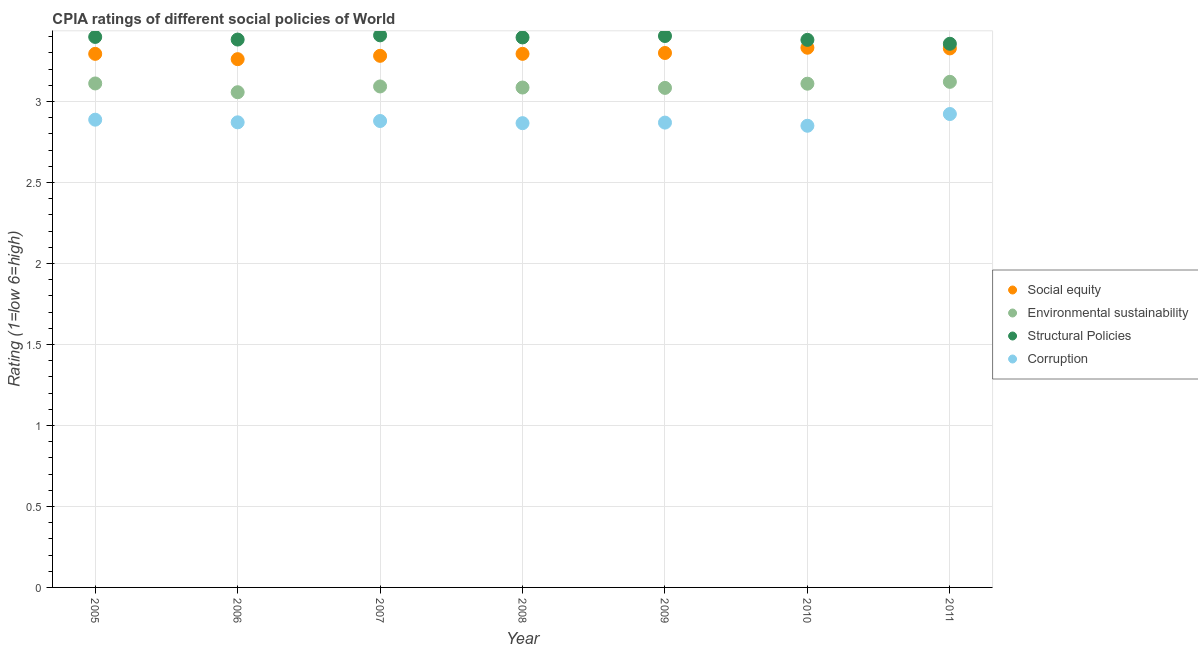How many different coloured dotlines are there?
Offer a very short reply. 4. Across all years, what is the maximum cpia rating of social equity?
Provide a succinct answer. 3.33. Across all years, what is the minimum cpia rating of social equity?
Ensure brevity in your answer.  3.26. In which year was the cpia rating of corruption maximum?
Your response must be concise. 2011. What is the total cpia rating of structural policies in the graph?
Ensure brevity in your answer.  23.73. What is the difference between the cpia rating of corruption in 2009 and that in 2010?
Offer a terse response. 0.02. What is the difference between the cpia rating of corruption in 2007 and the cpia rating of structural policies in 2005?
Your response must be concise. -0.52. What is the average cpia rating of structural policies per year?
Keep it short and to the point. 3.39. In the year 2011, what is the difference between the cpia rating of corruption and cpia rating of environmental sustainability?
Your answer should be very brief. -0.2. What is the ratio of the cpia rating of environmental sustainability in 2009 to that in 2011?
Provide a succinct answer. 0.99. Is the cpia rating of social equity in 2008 less than that in 2009?
Make the answer very short. Yes. Is the difference between the cpia rating of corruption in 2005 and 2011 greater than the difference between the cpia rating of environmental sustainability in 2005 and 2011?
Make the answer very short. No. What is the difference between the highest and the second highest cpia rating of structural policies?
Provide a short and direct response. 0. What is the difference between the highest and the lowest cpia rating of corruption?
Provide a short and direct response. 0.07. How many dotlines are there?
Keep it short and to the point. 4. What is the difference between two consecutive major ticks on the Y-axis?
Your answer should be compact. 0.5. Are the values on the major ticks of Y-axis written in scientific E-notation?
Your response must be concise. No. Does the graph contain grids?
Give a very brief answer. Yes. How are the legend labels stacked?
Your answer should be compact. Vertical. What is the title of the graph?
Make the answer very short. CPIA ratings of different social policies of World. Does "Regional development banks" appear as one of the legend labels in the graph?
Offer a very short reply. No. What is the label or title of the X-axis?
Your answer should be compact. Year. What is the Rating (1=low 6=high) in Social equity in 2005?
Your response must be concise. 3.29. What is the Rating (1=low 6=high) in Environmental sustainability in 2005?
Offer a terse response. 3.11. What is the Rating (1=low 6=high) in Structural Policies in 2005?
Keep it short and to the point. 3.4. What is the Rating (1=low 6=high) of Corruption in 2005?
Make the answer very short. 2.89. What is the Rating (1=low 6=high) of Social equity in 2006?
Your answer should be compact. 3.26. What is the Rating (1=low 6=high) of Environmental sustainability in 2006?
Provide a short and direct response. 3.06. What is the Rating (1=low 6=high) of Structural Policies in 2006?
Offer a very short reply. 3.38. What is the Rating (1=low 6=high) of Corruption in 2006?
Give a very brief answer. 2.87. What is the Rating (1=low 6=high) of Social equity in 2007?
Your answer should be very brief. 3.28. What is the Rating (1=low 6=high) of Environmental sustainability in 2007?
Keep it short and to the point. 3.09. What is the Rating (1=low 6=high) of Structural Policies in 2007?
Give a very brief answer. 3.41. What is the Rating (1=low 6=high) of Corruption in 2007?
Your answer should be very brief. 2.88. What is the Rating (1=low 6=high) of Social equity in 2008?
Your answer should be very brief. 3.29. What is the Rating (1=low 6=high) in Environmental sustainability in 2008?
Offer a terse response. 3.09. What is the Rating (1=low 6=high) in Structural Policies in 2008?
Your answer should be very brief. 3.4. What is the Rating (1=low 6=high) in Corruption in 2008?
Make the answer very short. 2.87. What is the Rating (1=low 6=high) in Environmental sustainability in 2009?
Ensure brevity in your answer.  3.08. What is the Rating (1=low 6=high) in Structural Policies in 2009?
Provide a succinct answer. 3.4. What is the Rating (1=low 6=high) in Corruption in 2009?
Your answer should be compact. 2.87. What is the Rating (1=low 6=high) in Social equity in 2010?
Your answer should be very brief. 3.33. What is the Rating (1=low 6=high) of Environmental sustainability in 2010?
Offer a very short reply. 3.11. What is the Rating (1=low 6=high) in Structural Policies in 2010?
Ensure brevity in your answer.  3.38. What is the Rating (1=low 6=high) of Corruption in 2010?
Keep it short and to the point. 2.85. What is the Rating (1=low 6=high) of Social equity in 2011?
Provide a short and direct response. 3.33. What is the Rating (1=low 6=high) of Environmental sustainability in 2011?
Offer a very short reply. 3.12. What is the Rating (1=low 6=high) in Structural Policies in 2011?
Provide a succinct answer. 3.36. What is the Rating (1=low 6=high) in Corruption in 2011?
Your answer should be compact. 2.92. Across all years, what is the maximum Rating (1=low 6=high) in Social equity?
Offer a very short reply. 3.33. Across all years, what is the maximum Rating (1=low 6=high) of Environmental sustainability?
Provide a succinct answer. 3.12. Across all years, what is the maximum Rating (1=low 6=high) in Structural Policies?
Provide a succinct answer. 3.41. Across all years, what is the maximum Rating (1=low 6=high) of Corruption?
Your response must be concise. 2.92. Across all years, what is the minimum Rating (1=low 6=high) of Social equity?
Keep it short and to the point. 3.26. Across all years, what is the minimum Rating (1=low 6=high) of Environmental sustainability?
Keep it short and to the point. 3.06. Across all years, what is the minimum Rating (1=low 6=high) of Structural Policies?
Keep it short and to the point. 3.36. Across all years, what is the minimum Rating (1=low 6=high) of Corruption?
Offer a terse response. 2.85. What is the total Rating (1=low 6=high) in Social equity in the graph?
Keep it short and to the point. 23.09. What is the total Rating (1=low 6=high) in Environmental sustainability in the graph?
Offer a terse response. 21.67. What is the total Rating (1=low 6=high) of Structural Policies in the graph?
Make the answer very short. 23.73. What is the total Rating (1=low 6=high) in Corruption in the graph?
Your response must be concise. 20.15. What is the difference between the Rating (1=low 6=high) of Social equity in 2005 and that in 2006?
Your answer should be compact. 0.03. What is the difference between the Rating (1=low 6=high) of Environmental sustainability in 2005 and that in 2006?
Ensure brevity in your answer.  0.05. What is the difference between the Rating (1=low 6=high) in Structural Policies in 2005 and that in 2006?
Your answer should be compact. 0.02. What is the difference between the Rating (1=low 6=high) in Corruption in 2005 and that in 2006?
Give a very brief answer. 0.02. What is the difference between the Rating (1=low 6=high) in Social equity in 2005 and that in 2007?
Your answer should be compact. 0.01. What is the difference between the Rating (1=low 6=high) of Environmental sustainability in 2005 and that in 2007?
Provide a succinct answer. 0.02. What is the difference between the Rating (1=low 6=high) of Structural Policies in 2005 and that in 2007?
Your response must be concise. -0.01. What is the difference between the Rating (1=low 6=high) in Corruption in 2005 and that in 2007?
Your answer should be very brief. 0.01. What is the difference between the Rating (1=low 6=high) in Social equity in 2005 and that in 2008?
Give a very brief answer. -0. What is the difference between the Rating (1=low 6=high) in Environmental sustainability in 2005 and that in 2008?
Provide a succinct answer. 0.03. What is the difference between the Rating (1=low 6=high) in Structural Policies in 2005 and that in 2008?
Make the answer very short. 0. What is the difference between the Rating (1=low 6=high) in Corruption in 2005 and that in 2008?
Offer a terse response. 0.02. What is the difference between the Rating (1=low 6=high) of Social equity in 2005 and that in 2009?
Provide a short and direct response. -0.01. What is the difference between the Rating (1=low 6=high) of Environmental sustainability in 2005 and that in 2009?
Provide a short and direct response. 0.03. What is the difference between the Rating (1=low 6=high) of Structural Policies in 2005 and that in 2009?
Offer a terse response. -0.01. What is the difference between the Rating (1=low 6=high) of Corruption in 2005 and that in 2009?
Make the answer very short. 0.02. What is the difference between the Rating (1=low 6=high) of Social equity in 2005 and that in 2010?
Your response must be concise. -0.04. What is the difference between the Rating (1=low 6=high) of Environmental sustainability in 2005 and that in 2010?
Offer a terse response. 0. What is the difference between the Rating (1=low 6=high) in Structural Policies in 2005 and that in 2010?
Offer a terse response. 0.02. What is the difference between the Rating (1=low 6=high) in Corruption in 2005 and that in 2010?
Your answer should be very brief. 0.04. What is the difference between the Rating (1=low 6=high) of Social equity in 2005 and that in 2011?
Provide a short and direct response. -0.03. What is the difference between the Rating (1=low 6=high) of Environmental sustainability in 2005 and that in 2011?
Ensure brevity in your answer.  -0.01. What is the difference between the Rating (1=low 6=high) of Structural Policies in 2005 and that in 2011?
Offer a very short reply. 0.04. What is the difference between the Rating (1=low 6=high) of Corruption in 2005 and that in 2011?
Provide a succinct answer. -0.03. What is the difference between the Rating (1=low 6=high) in Social equity in 2006 and that in 2007?
Give a very brief answer. -0.02. What is the difference between the Rating (1=low 6=high) of Environmental sustainability in 2006 and that in 2007?
Offer a very short reply. -0.04. What is the difference between the Rating (1=low 6=high) in Structural Policies in 2006 and that in 2007?
Ensure brevity in your answer.  -0.03. What is the difference between the Rating (1=low 6=high) of Corruption in 2006 and that in 2007?
Offer a very short reply. -0.01. What is the difference between the Rating (1=low 6=high) in Social equity in 2006 and that in 2008?
Offer a terse response. -0.03. What is the difference between the Rating (1=low 6=high) of Environmental sustainability in 2006 and that in 2008?
Make the answer very short. -0.03. What is the difference between the Rating (1=low 6=high) of Structural Policies in 2006 and that in 2008?
Your answer should be very brief. -0.01. What is the difference between the Rating (1=low 6=high) in Corruption in 2006 and that in 2008?
Provide a succinct answer. 0.01. What is the difference between the Rating (1=low 6=high) of Social equity in 2006 and that in 2009?
Provide a succinct answer. -0.04. What is the difference between the Rating (1=low 6=high) in Environmental sustainability in 2006 and that in 2009?
Offer a terse response. -0.03. What is the difference between the Rating (1=low 6=high) in Structural Policies in 2006 and that in 2009?
Your answer should be very brief. -0.02. What is the difference between the Rating (1=low 6=high) of Corruption in 2006 and that in 2009?
Make the answer very short. 0. What is the difference between the Rating (1=low 6=high) in Social equity in 2006 and that in 2010?
Your response must be concise. -0.07. What is the difference between the Rating (1=low 6=high) of Environmental sustainability in 2006 and that in 2010?
Your response must be concise. -0.05. What is the difference between the Rating (1=low 6=high) in Structural Policies in 2006 and that in 2010?
Your answer should be compact. 0. What is the difference between the Rating (1=low 6=high) in Corruption in 2006 and that in 2010?
Give a very brief answer. 0.02. What is the difference between the Rating (1=low 6=high) in Social equity in 2006 and that in 2011?
Make the answer very short. -0.07. What is the difference between the Rating (1=low 6=high) of Environmental sustainability in 2006 and that in 2011?
Give a very brief answer. -0.06. What is the difference between the Rating (1=low 6=high) of Structural Policies in 2006 and that in 2011?
Keep it short and to the point. 0.03. What is the difference between the Rating (1=low 6=high) of Corruption in 2006 and that in 2011?
Offer a terse response. -0.05. What is the difference between the Rating (1=low 6=high) of Social equity in 2007 and that in 2008?
Provide a short and direct response. -0.01. What is the difference between the Rating (1=low 6=high) of Environmental sustainability in 2007 and that in 2008?
Your answer should be very brief. 0.01. What is the difference between the Rating (1=low 6=high) in Structural Policies in 2007 and that in 2008?
Offer a terse response. 0.01. What is the difference between the Rating (1=low 6=high) of Corruption in 2007 and that in 2008?
Your response must be concise. 0.01. What is the difference between the Rating (1=low 6=high) of Social equity in 2007 and that in 2009?
Give a very brief answer. -0.02. What is the difference between the Rating (1=low 6=high) in Environmental sustainability in 2007 and that in 2009?
Keep it short and to the point. 0.01. What is the difference between the Rating (1=low 6=high) of Structural Policies in 2007 and that in 2009?
Provide a succinct answer. 0. What is the difference between the Rating (1=low 6=high) in Corruption in 2007 and that in 2009?
Make the answer very short. 0.01. What is the difference between the Rating (1=low 6=high) of Social equity in 2007 and that in 2010?
Your answer should be very brief. -0.05. What is the difference between the Rating (1=low 6=high) of Environmental sustainability in 2007 and that in 2010?
Your response must be concise. -0.02. What is the difference between the Rating (1=low 6=high) in Structural Policies in 2007 and that in 2010?
Provide a succinct answer. 0.03. What is the difference between the Rating (1=low 6=high) of Corruption in 2007 and that in 2010?
Your answer should be compact. 0.03. What is the difference between the Rating (1=low 6=high) of Social equity in 2007 and that in 2011?
Your answer should be very brief. -0.05. What is the difference between the Rating (1=low 6=high) of Environmental sustainability in 2007 and that in 2011?
Keep it short and to the point. -0.03. What is the difference between the Rating (1=low 6=high) in Structural Policies in 2007 and that in 2011?
Offer a terse response. 0.05. What is the difference between the Rating (1=low 6=high) of Corruption in 2007 and that in 2011?
Ensure brevity in your answer.  -0.04. What is the difference between the Rating (1=low 6=high) in Social equity in 2008 and that in 2009?
Provide a succinct answer. -0.01. What is the difference between the Rating (1=low 6=high) of Environmental sustainability in 2008 and that in 2009?
Your response must be concise. 0. What is the difference between the Rating (1=low 6=high) in Structural Policies in 2008 and that in 2009?
Give a very brief answer. -0.01. What is the difference between the Rating (1=low 6=high) of Corruption in 2008 and that in 2009?
Provide a succinct answer. -0. What is the difference between the Rating (1=low 6=high) of Social equity in 2008 and that in 2010?
Make the answer very short. -0.04. What is the difference between the Rating (1=low 6=high) of Environmental sustainability in 2008 and that in 2010?
Your answer should be compact. -0.02. What is the difference between the Rating (1=low 6=high) of Structural Policies in 2008 and that in 2010?
Make the answer very short. 0.01. What is the difference between the Rating (1=low 6=high) of Corruption in 2008 and that in 2010?
Make the answer very short. 0.02. What is the difference between the Rating (1=low 6=high) of Social equity in 2008 and that in 2011?
Your response must be concise. -0.03. What is the difference between the Rating (1=low 6=high) in Environmental sustainability in 2008 and that in 2011?
Your response must be concise. -0.04. What is the difference between the Rating (1=low 6=high) of Structural Policies in 2008 and that in 2011?
Ensure brevity in your answer.  0.04. What is the difference between the Rating (1=low 6=high) in Corruption in 2008 and that in 2011?
Provide a succinct answer. -0.06. What is the difference between the Rating (1=low 6=high) of Social equity in 2009 and that in 2010?
Your answer should be compact. -0.03. What is the difference between the Rating (1=low 6=high) of Environmental sustainability in 2009 and that in 2010?
Give a very brief answer. -0.03. What is the difference between the Rating (1=low 6=high) in Structural Policies in 2009 and that in 2010?
Make the answer very short. 0.02. What is the difference between the Rating (1=low 6=high) of Corruption in 2009 and that in 2010?
Offer a very short reply. 0.02. What is the difference between the Rating (1=low 6=high) of Social equity in 2009 and that in 2011?
Provide a short and direct response. -0.03. What is the difference between the Rating (1=low 6=high) of Environmental sustainability in 2009 and that in 2011?
Your answer should be very brief. -0.04. What is the difference between the Rating (1=low 6=high) in Structural Policies in 2009 and that in 2011?
Ensure brevity in your answer.  0.05. What is the difference between the Rating (1=low 6=high) of Corruption in 2009 and that in 2011?
Offer a terse response. -0.05. What is the difference between the Rating (1=low 6=high) in Social equity in 2010 and that in 2011?
Offer a very short reply. 0. What is the difference between the Rating (1=low 6=high) of Environmental sustainability in 2010 and that in 2011?
Offer a terse response. -0.01. What is the difference between the Rating (1=low 6=high) in Structural Policies in 2010 and that in 2011?
Your answer should be very brief. 0.02. What is the difference between the Rating (1=low 6=high) in Corruption in 2010 and that in 2011?
Keep it short and to the point. -0.07. What is the difference between the Rating (1=low 6=high) of Social equity in 2005 and the Rating (1=low 6=high) of Environmental sustainability in 2006?
Provide a short and direct response. 0.24. What is the difference between the Rating (1=low 6=high) in Social equity in 2005 and the Rating (1=low 6=high) in Structural Policies in 2006?
Ensure brevity in your answer.  -0.09. What is the difference between the Rating (1=low 6=high) of Social equity in 2005 and the Rating (1=low 6=high) of Corruption in 2006?
Make the answer very short. 0.42. What is the difference between the Rating (1=low 6=high) in Environmental sustainability in 2005 and the Rating (1=low 6=high) in Structural Policies in 2006?
Provide a succinct answer. -0.27. What is the difference between the Rating (1=low 6=high) in Environmental sustainability in 2005 and the Rating (1=low 6=high) in Corruption in 2006?
Give a very brief answer. 0.24. What is the difference between the Rating (1=low 6=high) of Structural Policies in 2005 and the Rating (1=low 6=high) of Corruption in 2006?
Your answer should be very brief. 0.53. What is the difference between the Rating (1=low 6=high) in Social equity in 2005 and the Rating (1=low 6=high) in Environmental sustainability in 2007?
Your response must be concise. 0.2. What is the difference between the Rating (1=low 6=high) in Social equity in 2005 and the Rating (1=low 6=high) in Structural Policies in 2007?
Keep it short and to the point. -0.11. What is the difference between the Rating (1=low 6=high) of Social equity in 2005 and the Rating (1=low 6=high) of Corruption in 2007?
Offer a terse response. 0.41. What is the difference between the Rating (1=low 6=high) in Environmental sustainability in 2005 and the Rating (1=low 6=high) in Structural Policies in 2007?
Ensure brevity in your answer.  -0.3. What is the difference between the Rating (1=low 6=high) in Environmental sustainability in 2005 and the Rating (1=low 6=high) in Corruption in 2007?
Provide a succinct answer. 0.23. What is the difference between the Rating (1=low 6=high) in Structural Policies in 2005 and the Rating (1=low 6=high) in Corruption in 2007?
Your answer should be compact. 0.52. What is the difference between the Rating (1=low 6=high) of Social equity in 2005 and the Rating (1=low 6=high) of Environmental sustainability in 2008?
Your answer should be compact. 0.21. What is the difference between the Rating (1=low 6=high) of Social equity in 2005 and the Rating (1=low 6=high) of Structural Policies in 2008?
Ensure brevity in your answer.  -0.1. What is the difference between the Rating (1=low 6=high) of Social equity in 2005 and the Rating (1=low 6=high) of Corruption in 2008?
Keep it short and to the point. 0.43. What is the difference between the Rating (1=low 6=high) of Environmental sustainability in 2005 and the Rating (1=low 6=high) of Structural Policies in 2008?
Provide a short and direct response. -0.28. What is the difference between the Rating (1=low 6=high) of Environmental sustainability in 2005 and the Rating (1=low 6=high) of Corruption in 2008?
Make the answer very short. 0.25. What is the difference between the Rating (1=low 6=high) of Structural Policies in 2005 and the Rating (1=low 6=high) of Corruption in 2008?
Offer a very short reply. 0.53. What is the difference between the Rating (1=low 6=high) of Social equity in 2005 and the Rating (1=low 6=high) of Environmental sustainability in 2009?
Ensure brevity in your answer.  0.21. What is the difference between the Rating (1=low 6=high) in Social equity in 2005 and the Rating (1=low 6=high) in Structural Policies in 2009?
Give a very brief answer. -0.11. What is the difference between the Rating (1=low 6=high) of Social equity in 2005 and the Rating (1=low 6=high) of Corruption in 2009?
Give a very brief answer. 0.42. What is the difference between the Rating (1=low 6=high) in Environmental sustainability in 2005 and the Rating (1=low 6=high) in Structural Policies in 2009?
Give a very brief answer. -0.29. What is the difference between the Rating (1=low 6=high) in Environmental sustainability in 2005 and the Rating (1=low 6=high) in Corruption in 2009?
Make the answer very short. 0.24. What is the difference between the Rating (1=low 6=high) in Structural Policies in 2005 and the Rating (1=low 6=high) in Corruption in 2009?
Provide a short and direct response. 0.53. What is the difference between the Rating (1=low 6=high) in Social equity in 2005 and the Rating (1=low 6=high) in Environmental sustainability in 2010?
Provide a succinct answer. 0.18. What is the difference between the Rating (1=low 6=high) of Social equity in 2005 and the Rating (1=low 6=high) of Structural Policies in 2010?
Your answer should be very brief. -0.09. What is the difference between the Rating (1=low 6=high) of Social equity in 2005 and the Rating (1=low 6=high) of Corruption in 2010?
Your answer should be compact. 0.44. What is the difference between the Rating (1=low 6=high) of Environmental sustainability in 2005 and the Rating (1=low 6=high) of Structural Policies in 2010?
Provide a short and direct response. -0.27. What is the difference between the Rating (1=low 6=high) in Environmental sustainability in 2005 and the Rating (1=low 6=high) in Corruption in 2010?
Your answer should be compact. 0.26. What is the difference between the Rating (1=low 6=high) in Structural Policies in 2005 and the Rating (1=low 6=high) in Corruption in 2010?
Give a very brief answer. 0.55. What is the difference between the Rating (1=low 6=high) of Social equity in 2005 and the Rating (1=low 6=high) of Environmental sustainability in 2011?
Offer a very short reply. 0.17. What is the difference between the Rating (1=low 6=high) in Social equity in 2005 and the Rating (1=low 6=high) in Structural Policies in 2011?
Give a very brief answer. -0.06. What is the difference between the Rating (1=low 6=high) in Social equity in 2005 and the Rating (1=low 6=high) in Corruption in 2011?
Your answer should be very brief. 0.37. What is the difference between the Rating (1=low 6=high) in Environmental sustainability in 2005 and the Rating (1=low 6=high) in Structural Policies in 2011?
Give a very brief answer. -0.24. What is the difference between the Rating (1=low 6=high) of Environmental sustainability in 2005 and the Rating (1=low 6=high) of Corruption in 2011?
Provide a short and direct response. 0.19. What is the difference between the Rating (1=low 6=high) in Structural Policies in 2005 and the Rating (1=low 6=high) in Corruption in 2011?
Provide a short and direct response. 0.48. What is the difference between the Rating (1=low 6=high) in Social equity in 2006 and the Rating (1=low 6=high) in Environmental sustainability in 2007?
Offer a very short reply. 0.17. What is the difference between the Rating (1=low 6=high) of Social equity in 2006 and the Rating (1=low 6=high) of Structural Policies in 2007?
Your response must be concise. -0.15. What is the difference between the Rating (1=low 6=high) of Social equity in 2006 and the Rating (1=low 6=high) of Corruption in 2007?
Your answer should be very brief. 0.38. What is the difference between the Rating (1=low 6=high) of Environmental sustainability in 2006 and the Rating (1=low 6=high) of Structural Policies in 2007?
Offer a very short reply. -0.35. What is the difference between the Rating (1=low 6=high) of Environmental sustainability in 2006 and the Rating (1=low 6=high) of Corruption in 2007?
Offer a terse response. 0.18. What is the difference between the Rating (1=low 6=high) of Structural Policies in 2006 and the Rating (1=low 6=high) of Corruption in 2007?
Ensure brevity in your answer.  0.5. What is the difference between the Rating (1=low 6=high) in Social equity in 2006 and the Rating (1=low 6=high) in Environmental sustainability in 2008?
Your answer should be compact. 0.18. What is the difference between the Rating (1=low 6=high) of Social equity in 2006 and the Rating (1=low 6=high) of Structural Policies in 2008?
Give a very brief answer. -0.13. What is the difference between the Rating (1=low 6=high) in Social equity in 2006 and the Rating (1=low 6=high) in Corruption in 2008?
Your response must be concise. 0.4. What is the difference between the Rating (1=low 6=high) of Environmental sustainability in 2006 and the Rating (1=low 6=high) of Structural Policies in 2008?
Make the answer very short. -0.34. What is the difference between the Rating (1=low 6=high) in Environmental sustainability in 2006 and the Rating (1=low 6=high) in Corruption in 2008?
Give a very brief answer. 0.19. What is the difference between the Rating (1=low 6=high) of Structural Policies in 2006 and the Rating (1=low 6=high) of Corruption in 2008?
Your response must be concise. 0.52. What is the difference between the Rating (1=low 6=high) of Social equity in 2006 and the Rating (1=low 6=high) of Environmental sustainability in 2009?
Your response must be concise. 0.18. What is the difference between the Rating (1=low 6=high) in Social equity in 2006 and the Rating (1=low 6=high) in Structural Policies in 2009?
Keep it short and to the point. -0.14. What is the difference between the Rating (1=low 6=high) of Social equity in 2006 and the Rating (1=low 6=high) of Corruption in 2009?
Provide a succinct answer. 0.39. What is the difference between the Rating (1=low 6=high) in Environmental sustainability in 2006 and the Rating (1=low 6=high) in Structural Policies in 2009?
Your answer should be compact. -0.35. What is the difference between the Rating (1=low 6=high) in Environmental sustainability in 2006 and the Rating (1=low 6=high) in Corruption in 2009?
Your response must be concise. 0.19. What is the difference between the Rating (1=low 6=high) in Structural Policies in 2006 and the Rating (1=low 6=high) in Corruption in 2009?
Your response must be concise. 0.51. What is the difference between the Rating (1=low 6=high) of Social equity in 2006 and the Rating (1=low 6=high) of Environmental sustainability in 2010?
Offer a terse response. 0.15. What is the difference between the Rating (1=low 6=high) of Social equity in 2006 and the Rating (1=low 6=high) of Structural Policies in 2010?
Offer a terse response. -0.12. What is the difference between the Rating (1=low 6=high) of Social equity in 2006 and the Rating (1=low 6=high) of Corruption in 2010?
Provide a succinct answer. 0.41. What is the difference between the Rating (1=low 6=high) in Environmental sustainability in 2006 and the Rating (1=low 6=high) in Structural Policies in 2010?
Offer a terse response. -0.32. What is the difference between the Rating (1=low 6=high) in Environmental sustainability in 2006 and the Rating (1=low 6=high) in Corruption in 2010?
Make the answer very short. 0.21. What is the difference between the Rating (1=low 6=high) of Structural Policies in 2006 and the Rating (1=low 6=high) of Corruption in 2010?
Offer a very short reply. 0.53. What is the difference between the Rating (1=low 6=high) in Social equity in 2006 and the Rating (1=low 6=high) in Environmental sustainability in 2011?
Make the answer very short. 0.14. What is the difference between the Rating (1=low 6=high) of Social equity in 2006 and the Rating (1=low 6=high) of Structural Policies in 2011?
Your answer should be compact. -0.1. What is the difference between the Rating (1=low 6=high) of Social equity in 2006 and the Rating (1=low 6=high) of Corruption in 2011?
Ensure brevity in your answer.  0.34. What is the difference between the Rating (1=low 6=high) in Environmental sustainability in 2006 and the Rating (1=low 6=high) in Structural Policies in 2011?
Offer a very short reply. -0.3. What is the difference between the Rating (1=low 6=high) in Environmental sustainability in 2006 and the Rating (1=low 6=high) in Corruption in 2011?
Your response must be concise. 0.13. What is the difference between the Rating (1=low 6=high) in Structural Policies in 2006 and the Rating (1=low 6=high) in Corruption in 2011?
Offer a terse response. 0.46. What is the difference between the Rating (1=low 6=high) in Social equity in 2007 and the Rating (1=low 6=high) in Environmental sustainability in 2008?
Ensure brevity in your answer.  0.2. What is the difference between the Rating (1=low 6=high) of Social equity in 2007 and the Rating (1=low 6=high) of Structural Policies in 2008?
Ensure brevity in your answer.  -0.11. What is the difference between the Rating (1=low 6=high) of Social equity in 2007 and the Rating (1=low 6=high) of Corruption in 2008?
Offer a very short reply. 0.42. What is the difference between the Rating (1=low 6=high) of Environmental sustainability in 2007 and the Rating (1=low 6=high) of Structural Policies in 2008?
Keep it short and to the point. -0.3. What is the difference between the Rating (1=low 6=high) of Environmental sustainability in 2007 and the Rating (1=low 6=high) of Corruption in 2008?
Offer a very short reply. 0.23. What is the difference between the Rating (1=low 6=high) in Structural Policies in 2007 and the Rating (1=low 6=high) in Corruption in 2008?
Ensure brevity in your answer.  0.54. What is the difference between the Rating (1=low 6=high) of Social equity in 2007 and the Rating (1=low 6=high) of Environmental sustainability in 2009?
Make the answer very short. 0.2. What is the difference between the Rating (1=low 6=high) of Social equity in 2007 and the Rating (1=low 6=high) of Structural Policies in 2009?
Your answer should be compact. -0.12. What is the difference between the Rating (1=low 6=high) of Social equity in 2007 and the Rating (1=low 6=high) of Corruption in 2009?
Provide a short and direct response. 0.41. What is the difference between the Rating (1=low 6=high) in Environmental sustainability in 2007 and the Rating (1=low 6=high) in Structural Policies in 2009?
Give a very brief answer. -0.31. What is the difference between the Rating (1=low 6=high) of Environmental sustainability in 2007 and the Rating (1=low 6=high) of Corruption in 2009?
Give a very brief answer. 0.22. What is the difference between the Rating (1=low 6=high) of Structural Policies in 2007 and the Rating (1=low 6=high) of Corruption in 2009?
Your answer should be compact. 0.54. What is the difference between the Rating (1=low 6=high) of Social equity in 2007 and the Rating (1=low 6=high) of Environmental sustainability in 2010?
Your answer should be very brief. 0.17. What is the difference between the Rating (1=low 6=high) in Social equity in 2007 and the Rating (1=low 6=high) in Structural Policies in 2010?
Offer a very short reply. -0.1. What is the difference between the Rating (1=low 6=high) in Social equity in 2007 and the Rating (1=low 6=high) in Corruption in 2010?
Provide a short and direct response. 0.43. What is the difference between the Rating (1=low 6=high) in Environmental sustainability in 2007 and the Rating (1=low 6=high) in Structural Policies in 2010?
Make the answer very short. -0.29. What is the difference between the Rating (1=low 6=high) in Environmental sustainability in 2007 and the Rating (1=low 6=high) in Corruption in 2010?
Give a very brief answer. 0.24. What is the difference between the Rating (1=low 6=high) in Structural Policies in 2007 and the Rating (1=low 6=high) in Corruption in 2010?
Provide a short and direct response. 0.56. What is the difference between the Rating (1=low 6=high) of Social equity in 2007 and the Rating (1=low 6=high) of Environmental sustainability in 2011?
Your response must be concise. 0.16. What is the difference between the Rating (1=low 6=high) of Social equity in 2007 and the Rating (1=low 6=high) of Structural Policies in 2011?
Keep it short and to the point. -0.07. What is the difference between the Rating (1=low 6=high) in Social equity in 2007 and the Rating (1=low 6=high) in Corruption in 2011?
Your response must be concise. 0.36. What is the difference between the Rating (1=low 6=high) of Environmental sustainability in 2007 and the Rating (1=low 6=high) of Structural Policies in 2011?
Ensure brevity in your answer.  -0.26. What is the difference between the Rating (1=low 6=high) of Environmental sustainability in 2007 and the Rating (1=low 6=high) of Corruption in 2011?
Offer a very short reply. 0.17. What is the difference between the Rating (1=low 6=high) in Structural Policies in 2007 and the Rating (1=low 6=high) in Corruption in 2011?
Your answer should be very brief. 0.49. What is the difference between the Rating (1=low 6=high) in Social equity in 2008 and the Rating (1=low 6=high) in Environmental sustainability in 2009?
Offer a terse response. 0.21. What is the difference between the Rating (1=low 6=high) in Social equity in 2008 and the Rating (1=low 6=high) in Structural Policies in 2009?
Keep it short and to the point. -0.11. What is the difference between the Rating (1=low 6=high) of Social equity in 2008 and the Rating (1=low 6=high) of Corruption in 2009?
Your answer should be very brief. 0.42. What is the difference between the Rating (1=low 6=high) of Environmental sustainability in 2008 and the Rating (1=low 6=high) of Structural Policies in 2009?
Provide a short and direct response. -0.32. What is the difference between the Rating (1=low 6=high) in Environmental sustainability in 2008 and the Rating (1=low 6=high) in Corruption in 2009?
Provide a succinct answer. 0.22. What is the difference between the Rating (1=low 6=high) of Structural Policies in 2008 and the Rating (1=low 6=high) of Corruption in 2009?
Make the answer very short. 0.53. What is the difference between the Rating (1=low 6=high) in Social equity in 2008 and the Rating (1=low 6=high) in Environmental sustainability in 2010?
Make the answer very short. 0.18. What is the difference between the Rating (1=low 6=high) of Social equity in 2008 and the Rating (1=low 6=high) of Structural Policies in 2010?
Keep it short and to the point. -0.09. What is the difference between the Rating (1=low 6=high) of Social equity in 2008 and the Rating (1=low 6=high) of Corruption in 2010?
Keep it short and to the point. 0.44. What is the difference between the Rating (1=low 6=high) of Environmental sustainability in 2008 and the Rating (1=low 6=high) of Structural Policies in 2010?
Offer a terse response. -0.29. What is the difference between the Rating (1=low 6=high) of Environmental sustainability in 2008 and the Rating (1=low 6=high) of Corruption in 2010?
Your answer should be very brief. 0.24. What is the difference between the Rating (1=low 6=high) of Structural Policies in 2008 and the Rating (1=low 6=high) of Corruption in 2010?
Give a very brief answer. 0.55. What is the difference between the Rating (1=low 6=high) in Social equity in 2008 and the Rating (1=low 6=high) in Environmental sustainability in 2011?
Your answer should be compact. 0.17. What is the difference between the Rating (1=low 6=high) in Social equity in 2008 and the Rating (1=low 6=high) in Structural Policies in 2011?
Make the answer very short. -0.06. What is the difference between the Rating (1=low 6=high) of Social equity in 2008 and the Rating (1=low 6=high) of Corruption in 2011?
Keep it short and to the point. 0.37. What is the difference between the Rating (1=low 6=high) in Environmental sustainability in 2008 and the Rating (1=low 6=high) in Structural Policies in 2011?
Provide a succinct answer. -0.27. What is the difference between the Rating (1=low 6=high) in Environmental sustainability in 2008 and the Rating (1=low 6=high) in Corruption in 2011?
Offer a very short reply. 0.16. What is the difference between the Rating (1=low 6=high) in Structural Policies in 2008 and the Rating (1=low 6=high) in Corruption in 2011?
Provide a succinct answer. 0.47. What is the difference between the Rating (1=low 6=high) of Social equity in 2009 and the Rating (1=low 6=high) of Environmental sustainability in 2010?
Your response must be concise. 0.19. What is the difference between the Rating (1=low 6=high) of Social equity in 2009 and the Rating (1=low 6=high) of Structural Policies in 2010?
Ensure brevity in your answer.  -0.08. What is the difference between the Rating (1=low 6=high) of Social equity in 2009 and the Rating (1=low 6=high) of Corruption in 2010?
Give a very brief answer. 0.45. What is the difference between the Rating (1=low 6=high) of Environmental sustainability in 2009 and the Rating (1=low 6=high) of Structural Policies in 2010?
Offer a very short reply. -0.3. What is the difference between the Rating (1=low 6=high) of Environmental sustainability in 2009 and the Rating (1=low 6=high) of Corruption in 2010?
Your answer should be compact. 0.23. What is the difference between the Rating (1=low 6=high) of Structural Policies in 2009 and the Rating (1=low 6=high) of Corruption in 2010?
Ensure brevity in your answer.  0.55. What is the difference between the Rating (1=low 6=high) in Social equity in 2009 and the Rating (1=low 6=high) in Environmental sustainability in 2011?
Your answer should be compact. 0.18. What is the difference between the Rating (1=low 6=high) of Social equity in 2009 and the Rating (1=low 6=high) of Structural Policies in 2011?
Your answer should be compact. -0.06. What is the difference between the Rating (1=low 6=high) of Social equity in 2009 and the Rating (1=low 6=high) of Corruption in 2011?
Your answer should be very brief. 0.38. What is the difference between the Rating (1=low 6=high) in Environmental sustainability in 2009 and the Rating (1=low 6=high) in Structural Policies in 2011?
Give a very brief answer. -0.27. What is the difference between the Rating (1=low 6=high) of Environmental sustainability in 2009 and the Rating (1=low 6=high) of Corruption in 2011?
Offer a very short reply. 0.16. What is the difference between the Rating (1=low 6=high) of Structural Policies in 2009 and the Rating (1=low 6=high) of Corruption in 2011?
Your response must be concise. 0.48. What is the difference between the Rating (1=low 6=high) in Social equity in 2010 and the Rating (1=low 6=high) in Environmental sustainability in 2011?
Ensure brevity in your answer.  0.21. What is the difference between the Rating (1=low 6=high) in Social equity in 2010 and the Rating (1=low 6=high) in Structural Policies in 2011?
Your answer should be compact. -0.02. What is the difference between the Rating (1=low 6=high) in Social equity in 2010 and the Rating (1=low 6=high) in Corruption in 2011?
Your response must be concise. 0.41. What is the difference between the Rating (1=low 6=high) in Environmental sustainability in 2010 and the Rating (1=low 6=high) in Structural Policies in 2011?
Make the answer very short. -0.25. What is the difference between the Rating (1=low 6=high) in Environmental sustainability in 2010 and the Rating (1=low 6=high) in Corruption in 2011?
Your response must be concise. 0.19. What is the difference between the Rating (1=low 6=high) in Structural Policies in 2010 and the Rating (1=low 6=high) in Corruption in 2011?
Offer a terse response. 0.46. What is the average Rating (1=low 6=high) in Social equity per year?
Ensure brevity in your answer.  3.3. What is the average Rating (1=low 6=high) of Environmental sustainability per year?
Offer a terse response. 3.1. What is the average Rating (1=low 6=high) of Structural Policies per year?
Your answer should be very brief. 3.39. What is the average Rating (1=low 6=high) of Corruption per year?
Your answer should be compact. 2.88. In the year 2005, what is the difference between the Rating (1=low 6=high) of Social equity and Rating (1=low 6=high) of Environmental sustainability?
Make the answer very short. 0.18. In the year 2005, what is the difference between the Rating (1=low 6=high) in Social equity and Rating (1=low 6=high) in Structural Policies?
Make the answer very short. -0.1. In the year 2005, what is the difference between the Rating (1=low 6=high) of Social equity and Rating (1=low 6=high) of Corruption?
Offer a terse response. 0.41. In the year 2005, what is the difference between the Rating (1=low 6=high) of Environmental sustainability and Rating (1=low 6=high) of Structural Policies?
Provide a succinct answer. -0.29. In the year 2005, what is the difference between the Rating (1=low 6=high) in Environmental sustainability and Rating (1=low 6=high) in Corruption?
Offer a terse response. 0.22. In the year 2005, what is the difference between the Rating (1=low 6=high) in Structural Policies and Rating (1=low 6=high) in Corruption?
Offer a very short reply. 0.51. In the year 2006, what is the difference between the Rating (1=low 6=high) in Social equity and Rating (1=low 6=high) in Environmental sustainability?
Ensure brevity in your answer.  0.2. In the year 2006, what is the difference between the Rating (1=low 6=high) of Social equity and Rating (1=low 6=high) of Structural Policies?
Provide a short and direct response. -0.12. In the year 2006, what is the difference between the Rating (1=low 6=high) in Social equity and Rating (1=low 6=high) in Corruption?
Offer a terse response. 0.39. In the year 2006, what is the difference between the Rating (1=low 6=high) of Environmental sustainability and Rating (1=low 6=high) of Structural Policies?
Your answer should be compact. -0.33. In the year 2006, what is the difference between the Rating (1=low 6=high) of Environmental sustainability and Rating (1=low 6=high) of Corruption?
Offer a terse response. 0.19. In the year 2006, what is the difference between the Rating (1=low 6=high) of Structural Policies and Rating (1=low 6=high) of Corruption?
Make the answer very short. 0.51. In the year 2007, what is the difference between the Rating (1=low 6=high) of Social equity and Rating (1=low 6=high) of Environmental sustainability?
Ensure brevity in your answer.  0.19. In the year 2007, what is the difference between the Rating (1=low 6=high) of Social equity and Rating (1=low 6=high) of Structural Policies?
Make the answer very short. -0.13. In the year 2007, what is the difference between the Rating (1=low 6=high) in Social equity and Rating (1=low 6=high) in Corruption?
Keep it short and to the point. 0.4. In the year 2007, what is the difference between the Rating (1=low 6=high) in Environmental sustainability and Rating (1=low 6=high) in Structural Policies?
Your answer should be very brief. -0.32. In the year 2007, what is the difference between the Rating (1=low 6=high) in Environmental sustainability and Rating (1=low 6=high) in Corruption?
Provide a short and direct response. 0.21. In the year 2007, what is the difference between the Rating (1=low 6=high) in Structural Policies and Rating (1=low 6=high) in Corruption?
Give a very brief answer. 0.53. In the year 2008, what is the difference between the Rating (1=low 6=high) of Social equity and Rating (1=low 6=high) of Environmental sustainability?
Your answer should be very brief. 0.21. In the year 2008, what is the difference between the Rating (1=low 6=high) in Social equity and Rating (1=low 6=high) in Structural Policies?
Your answer should be very brief. -0.1. In the year 2008, what is the difference between the Rating (1=low 6=high) of Social equity and Rating (1=low 6=high) of Corruption?
Your answer should be very brief. 0.43. In the year 2008, what is the difference between the Rating (1=low 6=high) in Environmental sustainability and Rating (1=low 6=high) in Structural Policies?
Give a very brief answer. -0.31. In the year 2008, what is the difference between the Rating (1=low 6=high) of Environmental sustainability and Rating (1=low 6=high) of Corruption?
Provide a succinct answer. 0.22. In the year 2008, what is the difference between the Rating (1=low 6=high) of Structural Policies and Rating (1=low 6=high) of Corruption?
Your answer should be compact. 0.53. In the year 2009, what is the difference between the Rating (1=low 6=high) of Social equity and Rating (1=low 6=high) of Environmental sustainability?
Your response must be concise. 0.22. In the year 2009, what is the difference between the Rating (1=low 6=high) of Social equity and Rating (1=low 6=high) of Structural Policies?
Your answer should be compact. -0.1. In the year 2009, what is the difference between the Rating (1=low 6=high) in Social equity and Rating (1=low 6=high) in Corruption?
Keep it short and to the point. 0.43. In the year 2009, what is the difference between the Rating (1=low 6=high) of Environmental sustainability and Rating (1=low 6=high) of Structural Policies?
Provide a short and direct response. -0.32. In the year 2009, what is the difference between the Rating (1=low 6=high) in Environmental sustainability and Rating (1=low 6=high) in Corruption?
Keep it short and to the point. 0.21. In the year 2009, what is the difference between the Rating (1=low 6=high) in Structural Policies and Rating (1=low 6=high) in Corruption?
Your answer should be very brief. 0.53. In the year 2010, what is the difference between the Rating (1=low 6=high) in Social equity and Rating (1=low 6=high) in Environmental sustainability?
Your response must be concise. 0.22. In the year 2010, what is the difference between the Rating (1=low 6=high) of Social equity and Rating (1=low 6=high) of Structural Policies?
Provide a short and direct response. -0.05. In the year 2010, what is the difference between the Rating (1=low 6=high) in Social equity and Rating (1=low 6=high) in Corruption?
Your answer should be compact. 0.48. In the year 2010, what is the difference between the Rating (1=low 6=high) of Environmental sustainability and Rating (1=low 6=high) of Structural Policies?
Offer a very short reply. -0.27. In the year 2010, what is the difference between the Rating (1=low 6=high) in Environmental sustainability and Rating (1=low 6=high) in Corruption?
Offer a very short reply. 0.26. In the year 2010, what is the difference between the Rating (1=low 6=high) of Structural Policies and Rating (1=low 6=high) of Corruption?
Your answer should be very brief. 0.53. In the year 2011, what is the difference between the Rating (1=low 6=high) of Social equity and Rating (1=low 6=high) of Environmental sustainability?
Your response must be concise. 0.21. In the year 2011, what is the difference between the Rating (1=low 6=high) in Social equity and Rating (1=low 6=high) in Structural Policies?
Offer a terse response. -0.03. In the year 2011, what is the difference between the Rating (1=low 6=high) of Social equity and Rating (1=low 6=high) of Corruption?
Your answer should be compact. 0.41. In the year 2011, what is the difference between the Rating (1=low 6=high) in Environmental sustainability and Rating (1=low 6=high) in Structural Policies?
Offer a terse response. -0.23. In the year 2011, what is the difference between the Rating (1=low 6=high) of Environmental sustainability and Rating (1=low 6=high) of Corruption?
Your answer should be very brief. 0.2. In the year 2011, what is the difference between the Rating (1=low 6=high) of Structural Policies and Rating (1=low 6=high) of Corruption?
Make the answer very short. 0.43. What is the ratio of the Rating (1=low 6=high) in Social equity in 2005 to that in 2006?
Your answer should be compact. 1.01. What is the ratio of the Rating (1=low 6=high) of Environmental sustainability in 2005 to that in 2006?
Provide a short and direct response. 1.02. What is the ratio of the Rating (1=low 6=high) of Structural Policies in 2005 to that in 2006?
Your answer should be very brief. 1. What is the ratio of the Rating (1=low 6=high) of Corruption in 2005 to that in 2006?
Make the answer very short. 1.01. What is the ratio of the Rating (1=low 6=high) in Social equity in 2005 to that in 2007?
Give a very brief answer. 1. What is the ratio of the Rating (1=low 6=high) in Structural Policies in 2005 to that in 2007?
Ensure brevity in your answer.  1. What is the ratio of the Rating (1=low 6=high) in Corruption in 2005 to that in 2007?
Ensure brevity in your answer.  1. What is the ratio of the Rating (1=low 6=high) of Environmental sustainability in 2005 to that in 2008?
Your answer should be compact. 1.01. What is the ratio of the Rating (1=low 6=high) of Corruption in 2005 to that in 2008?
Keep it short and to the point. 1.01. What is the ratio of the Rating (1=low 6=high) of Social equity in 2005 to that in 2009?
Your response must be concise. 1. What is the ratio of the Rating (1=low 6=high) in Environmental sustainability in 2005 to that in 2009?
Your answer should be compact. 1.01. What is the ratio of the Rating (1=low 6=high) in Corruption in 2005 to that in 2009?
Provide a succinct answer. 1.01. What is the ratio of the Rating (1=low 6=high) of Environmental sustainability in 2005 to that in 2010?
Provide a short and direct response. 1. What is the ratio of the Rating (1=low 6=high) of Structural Policies in 2005 to that in 2010?
Your answer should be compact. 1.01. What is the ratio of the Rating (1=low 6=high) of Corruption in 2005 to that in 2010?
Your answer should be very brief. 1.01. What is the ratio of the Rating (1=low 6=high) of Structural Policies in 2005 to that in 2011?
Offer a terse response. 1.01. What is the ratio of the Rating (1=low 6=high) in Corruption in 2005 to that in 2011?
Provide a succinct answer. 0.99. What is the ratio of the Rating (1=low 6=high) of Social equity in 2006 to that in 2007?
Your answer should be very brief. 0.99. What is the ratio of the Rating (1=low 6=high) in Structural Policies in 2006 to that in 2007?
Offer a very short reply. 0.99. What is the ratio of the Rating (1=low 6=high) of Environmental sustainability in 2006 to that in 2008?
Keep it short and to the point. 0.99. What is the ratio of the Rating (1=low 6=high) of Structural Policies in 2006 to that in 2008?
Offer a terse response. 1. What is the ratio of the Rating (1=low 6=high) in Social equity in 2006 to that in 2009?
Offer a very short reply. 0.99. What is the ratio of the Rating (1=low 6=high) of Social equity in 2006 to that in 2010?
Keep it short and to the point. 0.98. What is the ratio of the Rating (1=low 6=high) in Environmental sustainability in 2006 to that in 2010?
Provide a short and direct response. 0.98. What is the ratio of the Rating (1=low 6=high) of Corruption in 2006 to that in 2010?
Keep it short and to the point. 1.01. What is the ratio of the Rating (1=low 6=high) in Social equity in 2006 to that in 2011?
Make the answer very short. 0.98. What is the ratio of the Rating (1=low 6=high) in Environmental sustainability in 2006 to that in 2011?
Offer a terse response. 0.98. What is the ratio of the Rating (1=low 6=high) in Structural Policies in 2006 to that in 2011?
Your response must be concise. 1.01. What is the ratio of the Rating (1=low 6=high) of Corruption in 2006 to that in 2011?
Make the answer very short. 0.98. What is the ratio of the Rating (1=low 6=high) in Social equity in 2007 to that in 2008?
Provide a short and direct response. 1. What is the ratio of the Rating (1=low 6=high) of Structural Policies in 2007 to that in 2008?
Provide a short and direct response. 1. What is the ratio of the Rating (1=low 6=high) in Social equity in 2007 to that in 2009?
Your answer should be very brief. 0.99. What is the ratio of the Rating (1=low 6=high) of Environmental sustainability in 2007 to that in 2009?
Provide a short and direct response. 1. What is the ratio of the Rating (1=low 6=high) of Structural Policies in 2007 to that in 2009?
Your answer should be compact. 1. What is the ratio of the Rating (1=low 6=high) in Corruption in 2007 to that in 2009?
Ensure brevity in your answer.  1. What is the ratio of the Rating (1=low 6=high) of Social equity in 2007 to that in 2010?
Ensure brevity in your answer.  0.98. What is the ratio of the Rating (1=low 6=high) of Environmental sustainability in 2007 to that in 2010?
Offer a very short reply. 0.99. What is the ratio of the Rating (1=low 6=high) of Structural Policies in 2007 to that in 2010?
Your answer should be compact. 1.01. What is the ratio of the Rating (1=low 6=high) in Corruption in 2007 to that in 2010?
Ensure brevity in your answer.  1.01. What is the ratio of the Rating (1=low 6=high) of Social equity in 2007 to that in 2011?
Your response must be concise. 0.99. What is the ratio of the Rating (1=low 6=high) of Environmental sustainability in 2007 to that in 2011?
Give a very brief answer. 0.99. What is the ratio of the Rating (1=low 6=high) of Structural Policies in 2007 to that in 2011?
Make the answer very short. 1.02. What is the ratio of the Rating (1=low 6=high) of Corruption in 2007 to that in 2011?
Give a very brief answer. 0.99. What is the ratio of the Rating (1=low 6=high) in Corruption in 2008 to that in 2009?
Provide a succinct answer. 1. What is the ratio of the Rating (1=low 6=high) in Social equity in 2008 to that in 2010?
Offer a very short reply. 0.99. What is the ratio of the Rating (1=low 6=high) in Environmental sustainability in 2008 to that in 2010?
Your answer should be compact. 0.99. What is the ratio of the Rating (1=low 6=high) of Structural Policies in 2008 to that in 2010?
Keep it short and to the point. 1. What is the ratio of the Rating (1=low 6=high) in Corruption in 2008 to that in 2010?
Offer a very short reply. 1.01. What is the ratio of the Rating (1=low 6=high) of Environmental sustainability in 2008 to that in 2011?
Your answer should be compact. 0.99. What is the ratio of the Rating (1=low 6=high) of Structural Policies in 2008 to that in 2011?
Your answer should be compact. 1.01. What is the ratio of the Rating (1=low 6=high) in Corruption in 2008 to that in 2011?
Your answer should be compact. 0.98. What is the ratio of the Rating (1=low 6=high) of Social equity in 2009 to that in 2010?
Give a very brief answer. 0.99. What is the ratio of the Rating (1=low 6=high) in Corruption in 2009 to that in 2010?
Your answer should be compact. 1.01. What is the ratio of the Rating (1=low 6=high) in Structural Policies in 2009 to that in 2011?
Your answer should be compact. 1.01. What is the ratio of the Rating (1=low 6=high) in Corruption in 2009 to that in 2011?
Offer a terse response. 0.98. What is the ratio of the Rating (1=low 6=high) in Corruption in 2010 to that in 2011?
Offer a very short reply. 0.98. What is the difference between the highest and the second highest Rating (1=low 6=high) of Social equity?
Give a very brief answer. 0. What is the difference between the highest and the second highest Rating (1=low 6=high) in Structural Policies?
Make the answer very short. 0. What is the difference between the highest and the second highest Rating (1=low 6=high) in Corruption?
Your answer should be compact. 0.03. What is the difference between the highest and the lowest Rating (1=low 6=high) of Social equity?
Offer a terse response. 0.07. What is the difference between the highest and the lowest Rating (1=low 6=high) of Environmental sustainability?
Make the answer very short. 0.06. What is the difference between the highest and the lowest Rating (1=low 6=high) in Structural Policies?
Offer a very short reply. 0.05. What is the difference between the highest and the lowest Rating (1=low 6=high) in Corruption?
Offer a terse response. 0.07. 